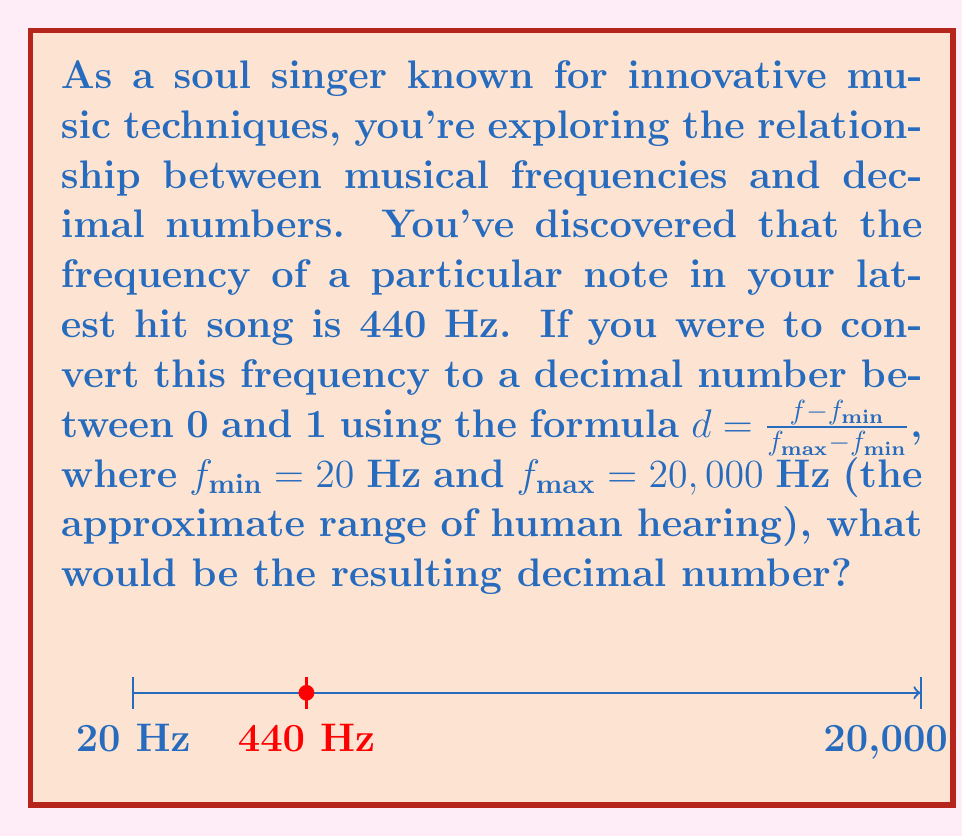What is the answer to this math problem? Let's approach this step-by-step:

1) We are given the formula:
   $$d = \frac{f - f_{min}}{f_{max} - f_{min}}$$

2) We know the following values:
   $f = 440$ Hz (the frequency of the note)
   $f_{min} = 20$ Hz
   $f_{max} = 20,000$ Hz

3) Let's substitute these values into the formula:
   $$d = \frac{440 - 20}{20,000 - 20}$$

4) Simplify the numerator and denominator:
   $$d = \frac{420}{19,980}$$

5) Divide the numerator by the denominator:
   $$d \approx 0.02102102...$$

6) Rounding to 5 decimal places for precision:
   $$d \approx 0.02102$$

This decimal represents the position of 440 Hz within the range of human hearing, normalized to a scale from 0 to 1.
Answer: $0.02102$ 